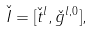Convert formula to latex. <formula><loc_0><loc_0><loc_500><loc_500>\check { I } = [ \check { t } ^ { l } , \check { g } ^ { l , 0 } ] ,</formula> 